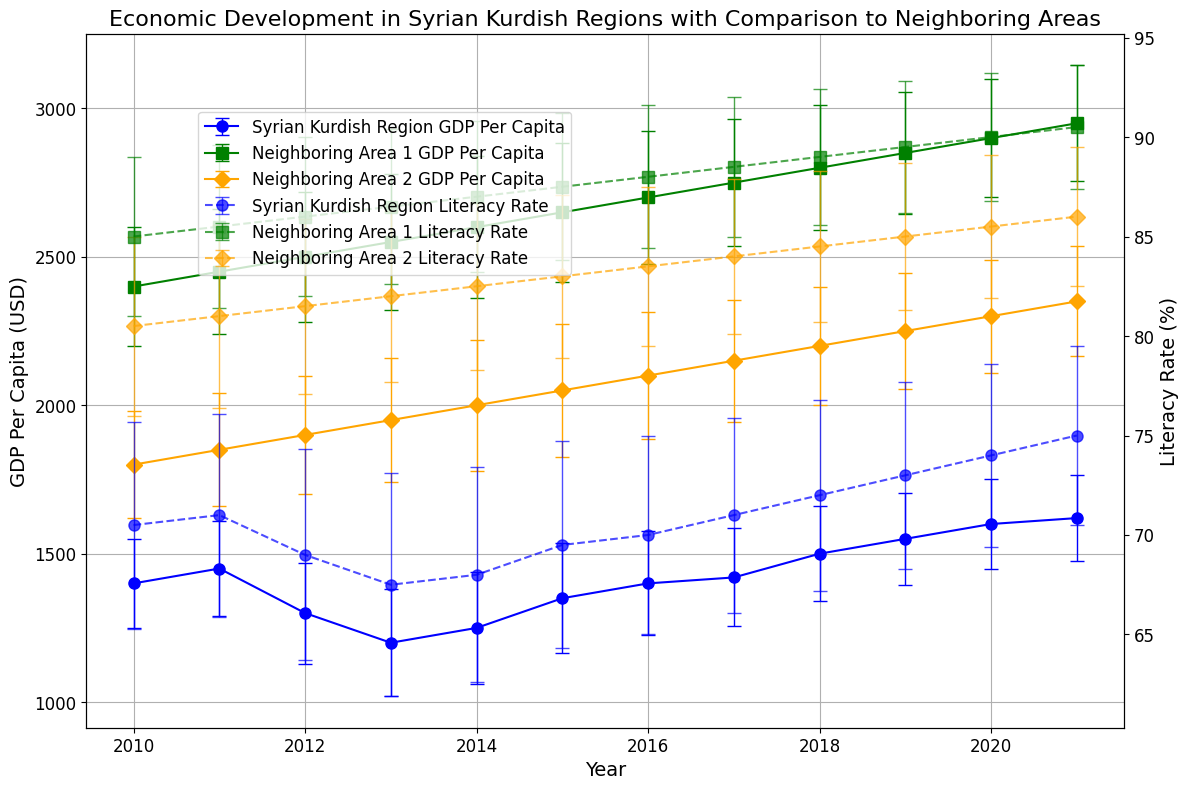What is the trend of GDP Per Capita in the Syrian Kurdish Region from 2010 to 2021? Observing the Syrian Kurdish Region's GDP Per Capita over the years, the plot shows fluctuations; initially, there is a drop between 2012 and 2013, followed by a gradual rise from 2014 to 2021, suggesting a recovery and growth.
Answer: Fluctuates, then increases How does the literacy rate trend differ between the Syrian Kurdish Region and Neighboring Area 1 from 2010 to 2021? The literacy rate in the Syrian Kurdish Region sees a gradual increase from 70.5% in 2010 to 75% in 2021. However, Neighboring Area 1 starts higher at 85% and steadily increases to 90.5%, showcasing a consistently higher and steadily growing literacy rate.
Answer: Neighboring Area 1 has consistently higher and steadily increasing literacy rates In what year did the Syrian Kurdish Region have its lowest GDP Per Capita, and what was the value? From the plot, the lowest GDP Per Capita for the Syrian Kurdish Region occurs in the year 2013 with a value of around 1200 USD.
Answer: 2013, 1200 USD Between 2015 and 2019, which region had the most significant increase in GDP Per Capita? Calculating the difference in GDP Per Capita for each region between 2015 and 2019: 
- Syrian Kurdish Region: 1550 - 1350 = 200 USD 
- Neighboring Area 1: 2850 - 2650 = 200 USD 
- Neighboring Area 2: 2250 - 2050 = 200 USD
All regions had the same increase of 200 USD.
Answer: All regions, 200 USD Which region had the highest uncertainty (standard deviation) in GDP Per Capita in 2014, and what was the value? From the plot, Neighboring Area 1 shows error bars that indicate the largest uncertainty in 2014 with a Standard Deviation of around 240.
Answer: Neighboring Area 1, 240 How do the error bars for literacy rates compare between the regions in 2020? In 2020, the plot shows that the Syrian Kurdish Region has error bars indicating a Standard Deviation (uncertainty) of around 4.6, Neighboring Area 1 has a lower uncertainty with around 3.2, and Neighboring Area 2 has about 3.6, indicating that the Syrian Kurdish Region has the highest uncertainty in literacy rates.
Answer: Syrian Kurdish Region has the highest uncertainty Which region showed the largest improvement in literacy rate from 2010 to 2021? Calculating the difference in literacy rates from 2010 to 2021 for each region:
- Syrian Kurdish Region: 75.0% - 70.5% = 4.5%
- Neighboring Area 1: 90.5% - 85.0% = 5.5%
- Neighboring Area 2: 86.0% - 80.5% = 5.5%
Neighboring Area 1 and Neighboring Area 2 both show the largest improvements, each with a 5.5% increase.
Answer: Neighboring Area 1 and Neighboring Area 2, 5.5% Which region demonstrated the least fluctuation in GDP per capita from 2010 to 2021? By observing the error bars (standard deviations) across the years, Neighboring Area 2 demonstrates the least fluctuation in GDP Per Capita, having relatively narrow error bands and consistent increases compared to the other regions.
Answer: Neighboring Area 2 In which year did the Syrian Kurdish Region have the highest literacy rate, and what was the value? From the plot, the Syrian Kurdish Region's highest literacy rate occurs in the year 2021, reaching approximately 75%.
Answer: 2021, 75% Between Neighboring Area 1 and Neighboring Area 2, which had a greater literacy increase percentage from 2010 to 2021? Calculating the percentage increase for the regions:
- Neighboring Area 1: ((90.5 - 85.0) / 85.0) * 100 ≈ 6.47%
- Neighboring Area 2: ((86.0 - 80.5) / 80.5) * 100 ≈ 6.83%
Neighboring Area 2 shows a slightly greater percentage increase in literacy rate.
Answer: Neighboring Area 2, ≈ 6.83% 